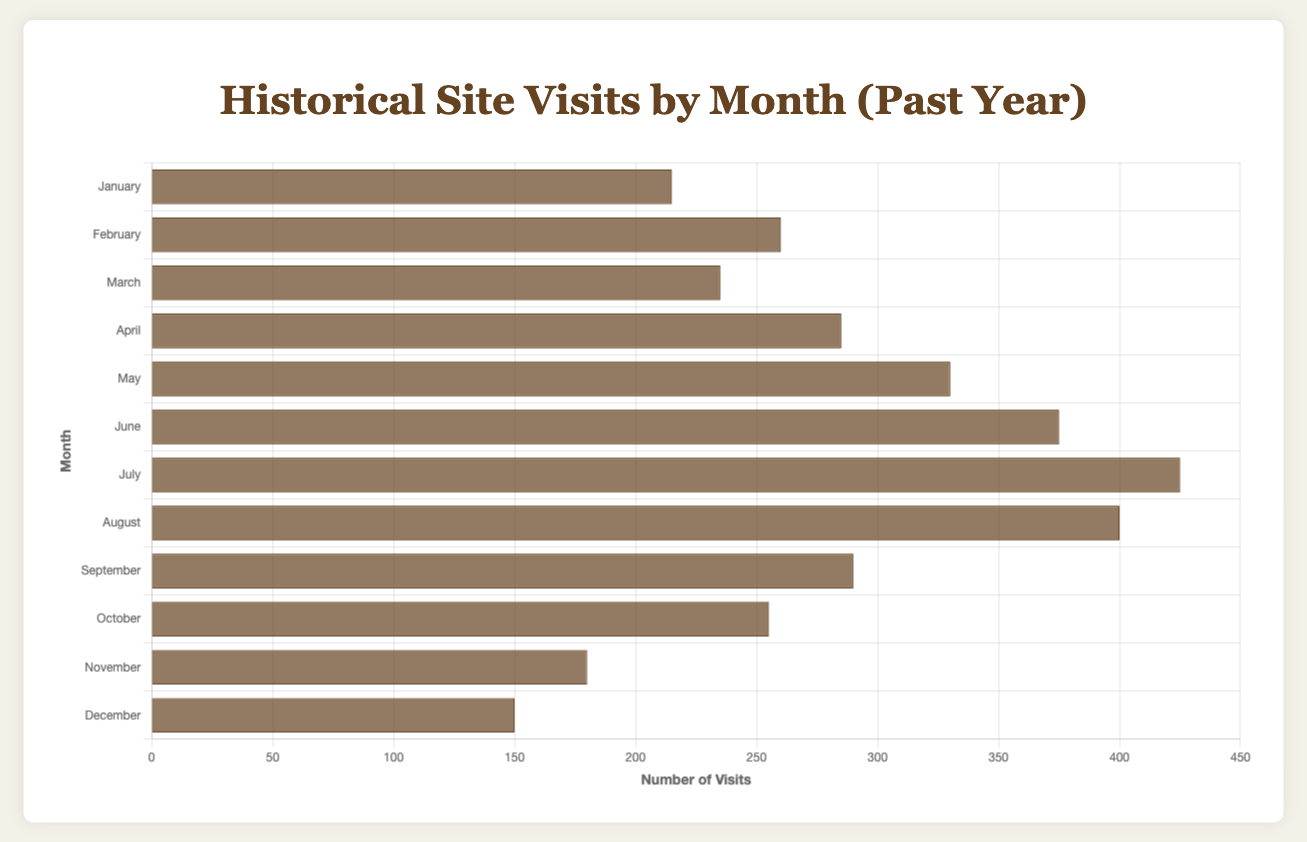What is the total number of site visits in July? The total number of visits in July is the sum of visits for the "Statue of Liberty" (230) and "Ellis Island" (195): 230 + 195 = 425
Answer: 425 Which month has the highest total number of visits? By observing the height of the bars in the chart, July has the highest total number of visits with 425 visits.
Answer: July How does the number of visits in January compare to February? January has 120 (Fort Sumter National Monument) + 95 (Alcatraz Island) = 215 visits. February has 150 (Gettysburg National Military Park) + 110 (Independence Hall) = 260 visits. February has more visits: 260 - 215 = 45 more visits.
Answer: February has 45 more visits What is the average number of visits in April? The average is calculated by summing the visits in April (170 + 115 = 285) and dividing by the number of sites (2). 285 / 2 = 142.5
Answer: 142.5 Which month has fewer visits, November or December? November has 95 (Yorktown Battlefield) + 85 (Harriet Tubman Home) = 180 visits. December has 80 (Mount Rushmore) + 70 (Harpers Ferry) = 150 visits. December has fewer visits.
Answer: December Are there more visits in March or October? March has 130 (Liberty Bell) + 105 (The Alamo) = 235 visits. October has 145 (Salem Witch Museum) + 110 (Jamestown Settlement) = 255 visits. October has more visits.
Answer: October In which month does Mount Vernon have the most visits? Mount Vernon only appears once, in April, with 170 visits.
Answer: April Which site has more visits in May, Colonial Williamsburg or Plymouth Rock? Colonial Williamsburg has 190 visits and Plymouth Rock has 140 visits. Colonial Williamsburg has more visits.
Answer: Colonial Williamsburg Which month has the least total visits overall? By comparing the heights of the bars, December has the least total visits with 150.
Answer: December 